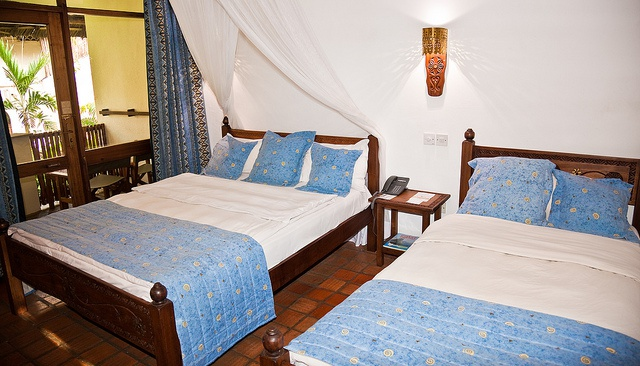Describe the objects in this image and their specific colors. I can see bed in black, lightgray, lightblue, and darkgray tones, bed in black, lightgray, darkgray, and gray tones, chair in black, maroon, and white tones, chair in black, maroon, and olive tones, and chair in black, maroon, and olive tones in this image. 